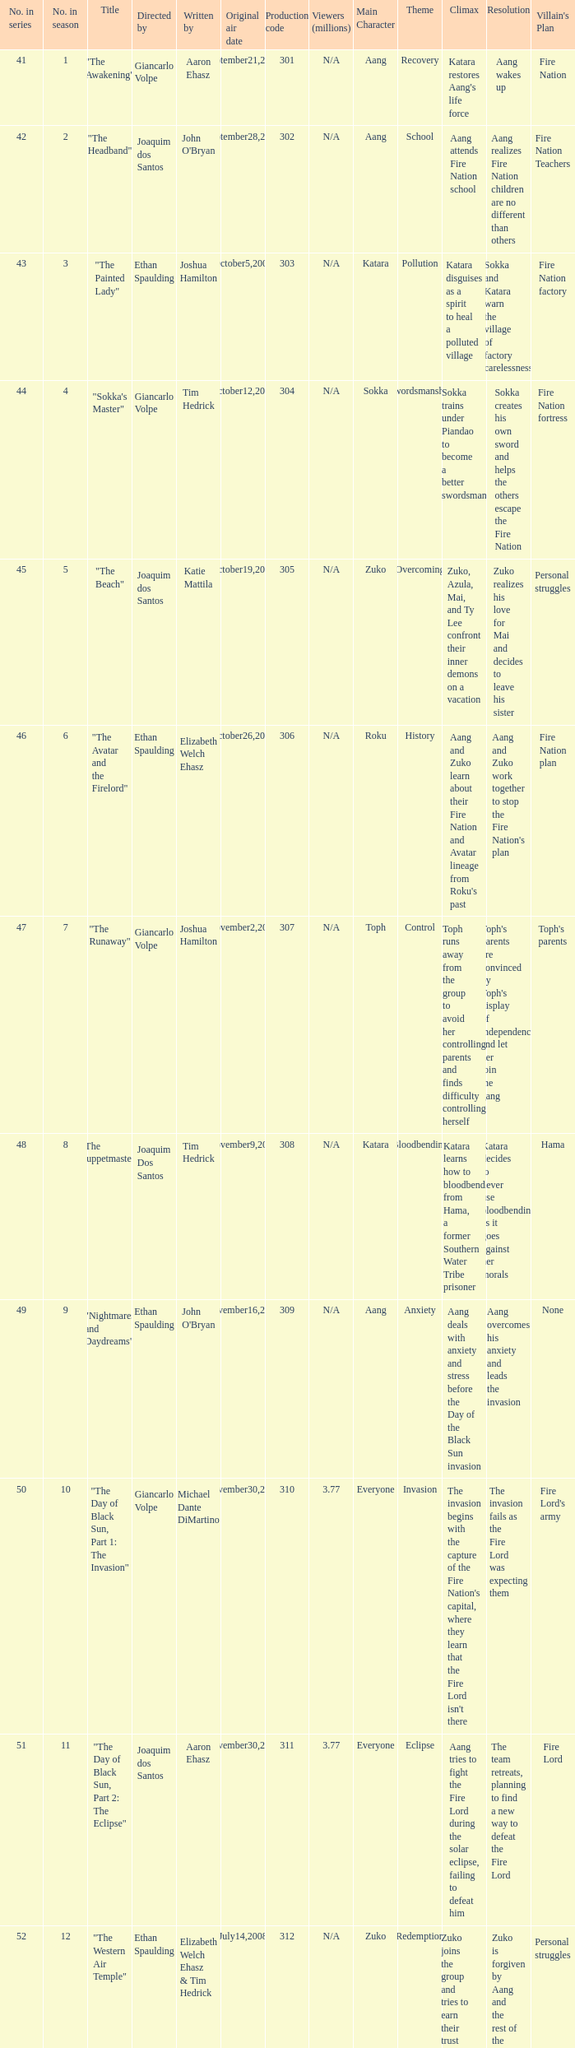What season has an episode written by john o'bryan and directed by ethan spaulding? 9.0. 